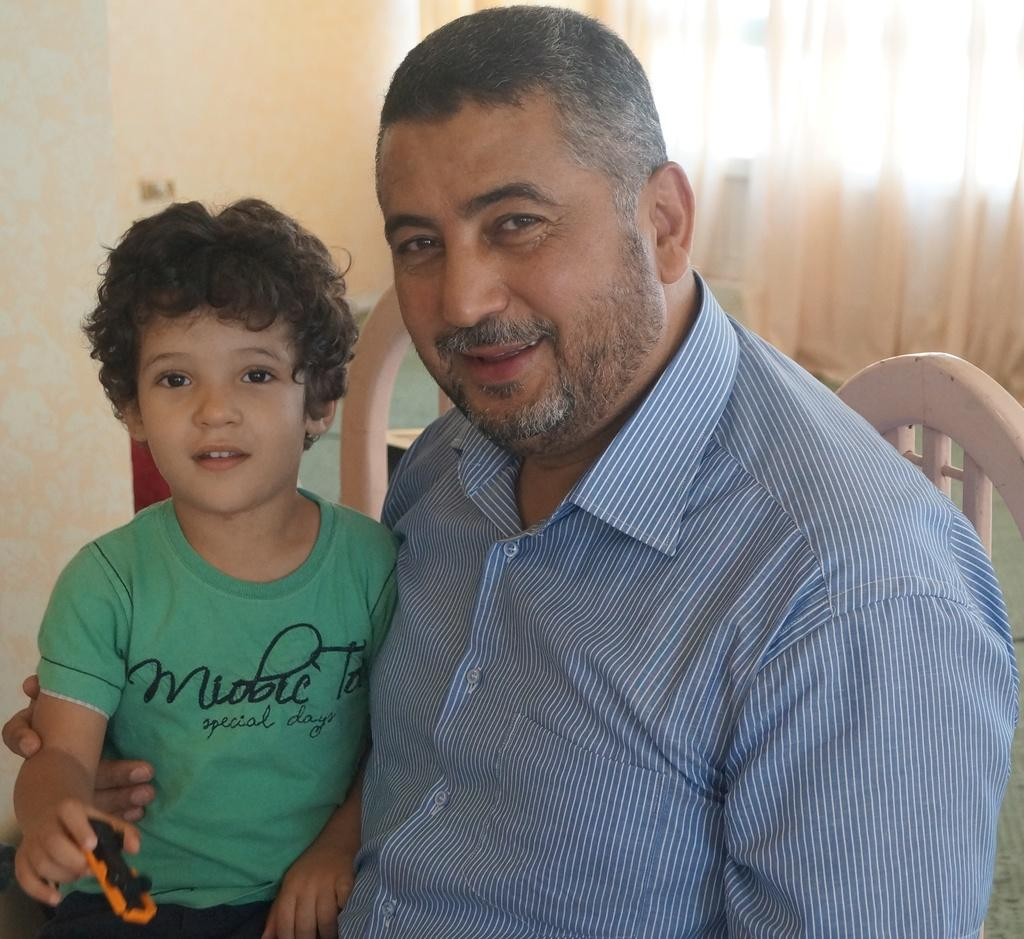What is the man doing in the image? The man is sitting on a chair in the image. Who is sitting beside the man? There is a boy sitting beside the man in the image. What is the boy holding in the image? The boy is holding an orange-colored toy in the image. What can be seen in the background of the image? There are curtains visible in the background of the image. How many pigs are visible in the image? There are no pigs visible in the image. What is the result of adding the man and the boy together in the image? This question does not make sense in the context of the image, as it is not about performing mathematical operations on the subjects. 